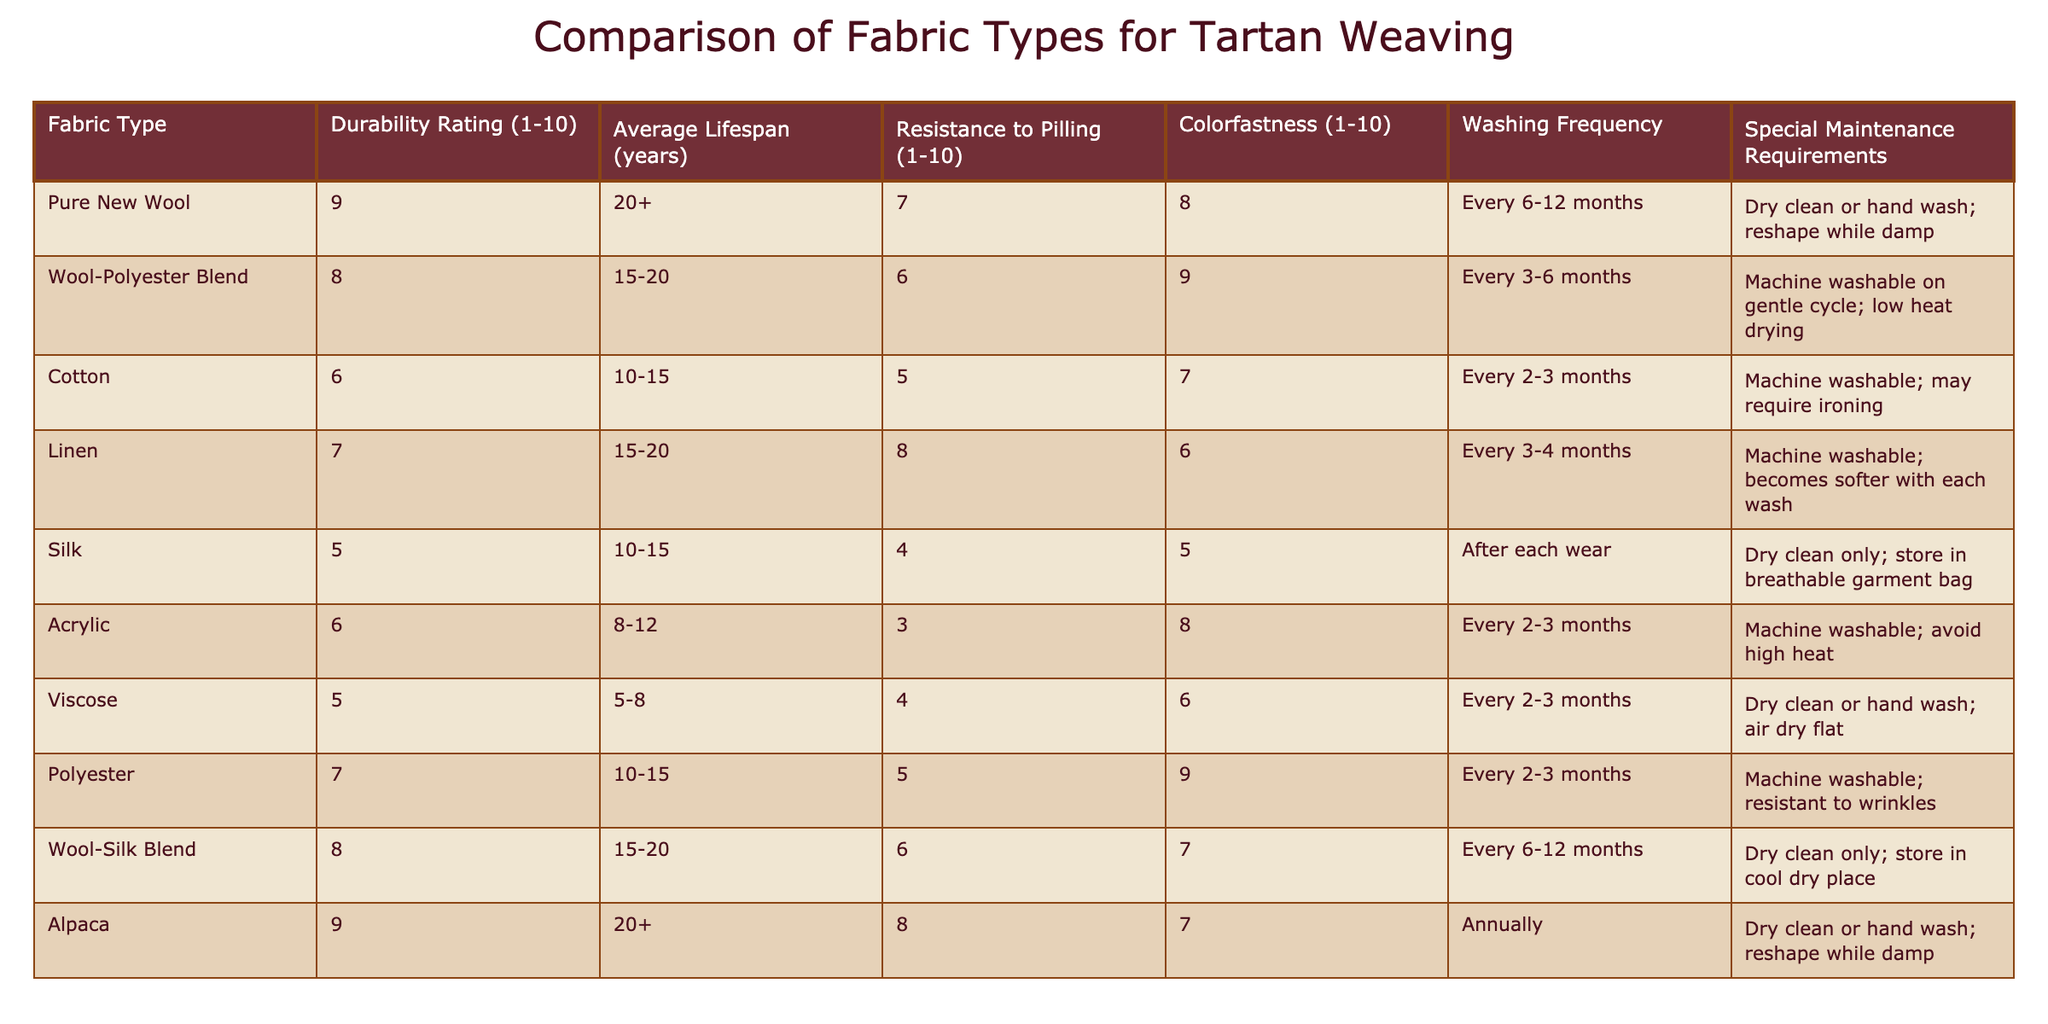What is the durability rating of Pure New Wool? The durability rating is listed directly in the table under the "Durability Rating (1-10)" column for Pure New Wool, which shows a value of 9.
Answer: 9 Which fabric type has the highest average lifespan? By examining the "Average Lifespan (years)" column, both Pure New Wool and Alpaca have an average lifespan of 20+ years, which is the highest value in the table.
Answer: Pure New Wool and Alpaca Is the Wool-Polyester Blend more resistant to pilling than Acrylic? The "Resistance to Pilling (1-10)" column shows that Wool-Polyester Blend has a rating of 6 while Acrylic is rated at 3. Since 6 is greater than 3, Wool-Polyester Blend is indeed more resistant to pilling.
Answer: Yes What is the average colorfastness rating for fabrics with a durability rating of 8 or higher? First identify the fabrics with a durability rating of 8 or higher: Pure New Wool (8), Wool-Polyester Blend (8), and Alpaca (7). Their colorfastness ratings are 8, 9, and 7 respectively. The average is (8 + 9 + 7) / 3 = 8.
Answer: 8 Does Silk require more frequent washing than Linen? The "Washing Frequency" column indicates that Silk is to be washed after each wear, while Linen requires washing every 3-4 months. Since "after each wear" is more frequent than "every 3-4 months," the answer is yes.
Answer: Yes How much longer is the average lifespan of Alpaca compared to Silk? The average lifespan for Alpaca is 20+ years and for Silk it is 10-15 years. If we consider the minimum lifespan for Silk as 10 years, the difference is 20 - 10 = 10 years. Thus, Alpaca has an average lifespan of at least 10 years longer than Silk.
Answer: 10 years Which fabric type has the least maintenance requirements? By analyzing the "Special Maintenance Requirements" column, Silk and its requirement of "Dry clean only; store in breathable garment bag" is compared with others. Notable for less maintenance, Cotton is "Machine washable; may require ironing," generally considered less demanding. Therefore, Cotton has the least maintenance requirement.
Answer: Cotton What is the total number of fabrics that require dry cleaning only? By checking the "Special Maintenance Requirements" column, Silk and Wool-Silk Blend need dry cleaning only. Thus, the total number is 2.
Answer: 2 Is it true that Polyester has a higher colorfastness rating than Cotton? In the "Colorfastness (1-10)" column, Polyester has a rating of 9 while Cotton has a rating of 7. Since 9 is greater than 7, it is true that Polyester has a higher colorfastness rating than Cotton.
Answer: Yes 